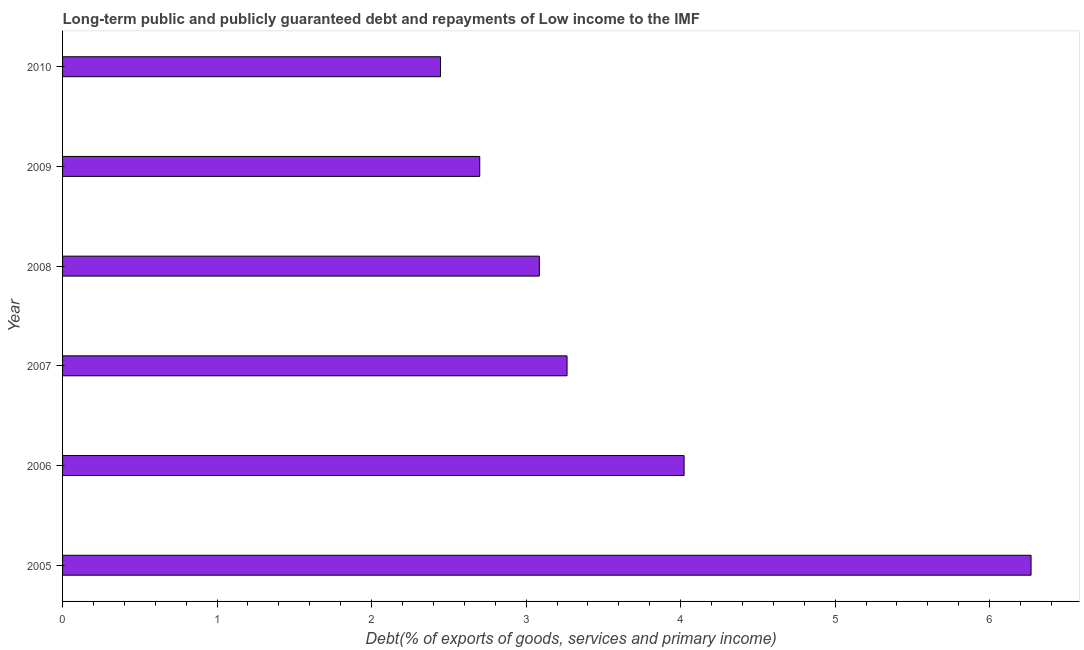What is the title of the graph?
Your answer should be compact. Long-term public and publicly guaranteed debt and repayments of Low income to the IMF. What is the label or title of the X-axis?
Offer a terse response. Debt(% of exports of goods, services and primary income). What is the debt service in 2009?
Your answer should be compact. 2.7. Across all years, what is the maximum debt service?
Give a very brief answer. 6.27. Across all years, what is the minimum debt service?
Offer a very short reply. 2.45. In which year was the debt service minimum?
Provide a succinct answer. 2010. What is the sum of the debt service?
Your answer should be very brief. 21.79. What is the difference between the debt service in 2006 and 2010?
Keep it short and to the point. 1.58. What is the average debt service per year?
Your response must be concise. 3.63. What is the median debt service?
Your answer should be compact. 3.18. In how many years, is the debt service greater than 0.4 %?
Your response must be concise. 6. Do a majority of the years between 2007 and 2005 (inclusive) have debt service greater than 6 %?
Offer a terse response. Yes. What is the ratio of the debt service in 2006 to that in 2009?
Give a very brief answer. 1.49. Is the difference between the debt service in 2008 and 2009 greater than the difference between any two years?
Your answer should be very brief. No. What is the difference between the highest and the second highest debt service?
Ensure brevity in your answer.  2.25. What is the difference between the highest and the lowest debt service?
Ensure brevity in your answer.  3.82. How many years are there in the graph?
Your answer should be compact. 6. Are the values on the major ticks of X-axis written in scientific E-notation?
Offer a terse response. No. What is the Debt(% of exports of goods, services and primary income) in 2005?
Your response must be concise. 6.27. What is the Debt(% of exports of goods, services and primary income) of 2006?
Make the answer very short. 4.02. What is the Debt(% of exports of goods, services and primary income) of 2007?
Offer a terse response. 3.27. What is the Debt(% of exports of goods, services and primary income) of 2008?
Offer a very short reply. 3.09. What is the Debt(% of exports of goods, services and primary income) in 2009?
Offer a very short reply. 2.7. What is the Debt(% of exports of goods, services and primary income) in 2010?
Your response must be concise. 2.45. What is the difference between the Debt(% of exports of goods, services and primary income) in 2005 and 2006?
Ensure brevity in your answer.  2.25. What is the difference between the Debt(% of exports of goods, services and primary income) in 2005 and 2007?
Provide a short and direct response. 3. What is the difference between the Debt(% of exports of goods, services and primary income) in 2005 and 2008?
Your response must be concise. 3.18. What is the difference between the Debt(% of exports of goods, services and primary income) in 2005 and 2009?
Make the answer very short. 3.57. What is the difference between the Debt(% of exports of goods, services and primary income) in 2005 and 2010?
Your answer should be compact. 3.82. What is the difference between the Debt(% of exports of goods, services and primary income) in 2006 and 2007?
Make the answer very short. 0.76. What is the difference between the Debt(% of exports of goods, services and primary income) in 2006 and 2008?
Offer a very short reply. 0.94. What is the difference between the Debt(% of exports of goods, services and primary income) in 2006 and 2009?
Your response must be concise. 1.32. What is the difference between the Debt(% of exports of goods, services and primary income) in 2006 and 2010?
Offer a terse response. 1.58. What is the difference between the Debt(% of exports of goods, services and primary income) in 2007 and 2008?
Provide a succinct answer. 0.18. What is the difference between the Debt(% of exports of goods, services and primary income) in 2007 and 2009?
Make the answer very short. 0.56. What is the difference between the Debt(% of exports of goods, services and primary income) in 2007 and 2010?
Give a very brief answer. 0.82. What is the difference between the Debt(% of exports of goods, services and primary income) in 2008 and 2009?
Give a very brief answer. 0.39. What is the difference between the Debt(% of exports of goods, services and primary income) in 2008 and 2010?
Ensure brevity in your answer.  0.64. What is the difference between the Debt(% of exports of goods, services and primary income) in 2009 and 2010?
Provide a short and direct response. 0.25. What is the ratio of the Debt(% of exports of goods, services and primary income) in 2005 to that in 2006?
Keep it short and to the point. 1.56. What is the ratio of the Debt(% of exports of goods, services and primary income) in 2005 to that in 2007?
Your response must be concise. 1.92. What is the ratio of the Debt(% of exports of goods, services and primary income) in 2005 to that in 2008?
Offer a very short reply. 2.03. What is the ratio of the Debt(% of exports of goods, services and primary income) in 2005 to that in 2009?
Provide a short and direct response. 2.32. What is the ratio of the Debt(% of exports of goods, services and primary income) in 2005 to that in 2010?
Provide a succinct answer. 2.56. What is the ratio of the Debt(% of exports of goods, services and primary income) in 2006 to that in 2007?
Offer a very short reply. 1.23. What is the ratio of the Debt(% of exports of goods, services and primary income) in 2006 to that in 2008?
Keep it short and to the point. 1.3. What is the ratio of the Debt(% of exports of goods, services and primary income) in 2006 to that in 2009?
Your answer should be compact. 1.49. What is the ratio of the Debt(% of exports of goods, services and primary income) in 2006 to that in 2010?
Make the answer very short. 1.64. What is the ratio of the Debt(% of exports of goods, services and primary income) in 2007 to that in 2008?
Ensure brevity in your answer.  1.06. What is the ratio of the Debt(% of exports of goods, services and primary income) in 2007 to that in 2009?
Provide a short and direct response. 1.21. What is the ratio of the Debt(% of exports of goods, services and primary income) in 2007 to that in 2010?
Ensure brevity in your answer.  1.33. What is the ratio of the Debt(% of exports of goods, services and primary income) in 2008 to that in 2009?
Your answer should be compact. 1.14. What is the ratio of the Debt(% of exports of goods, services and primary income) in 2008 to that in 2010?
Give a very brief answer. 1.26. What is the ratio of the Debt(% of exports of goods, services and primary income) in 2009 to that in 2010?
Make the answer very short. 1.1. 